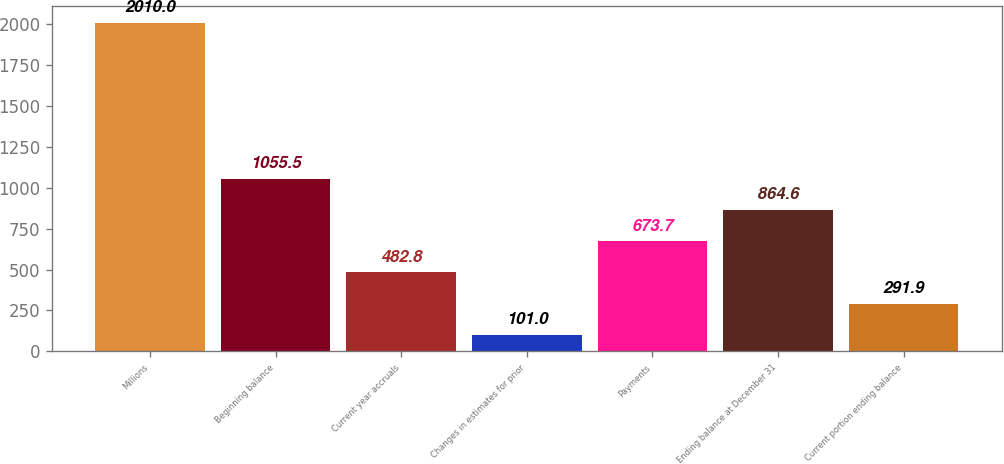<chart> <loc_0><loc_0><loc_500><loc_500><bar_chart><fcel>Millions<fcel>Beginning balance<fcel>Current year accruals<fcel>Changes in estimates for prior<fcel>Payments<fcel>Ending balance at December 31<fcel>Current portion ending balance<nl><fcel>2010<fcel>1055.5<fcel>482.8<fcel>101<fcel>673.7<fcel>864.6<fcel>291.9<nl></chart> 